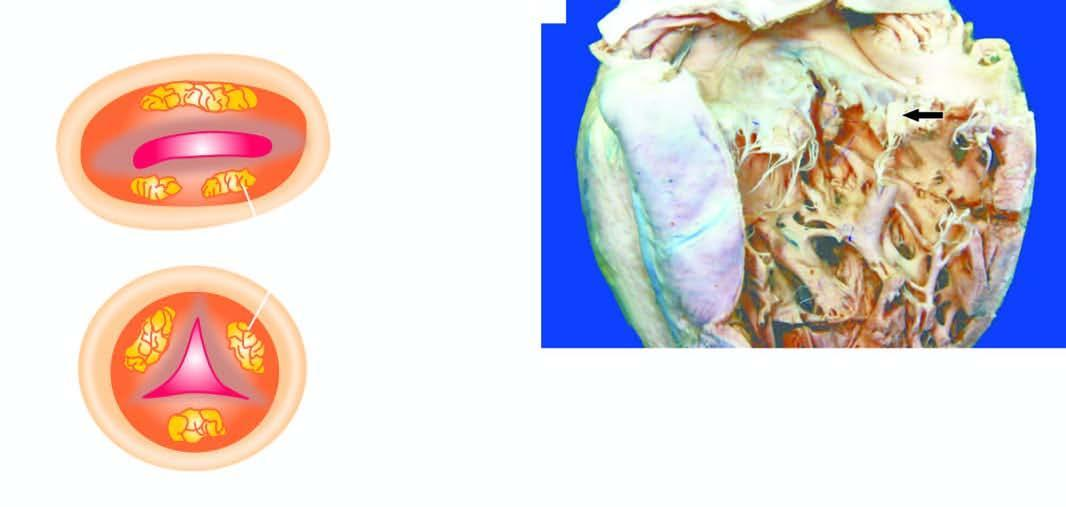re the vegetations shown on the mitral valve are shown as seen from the left ventricle?
Answer the question using a single word or phrase. Yes 